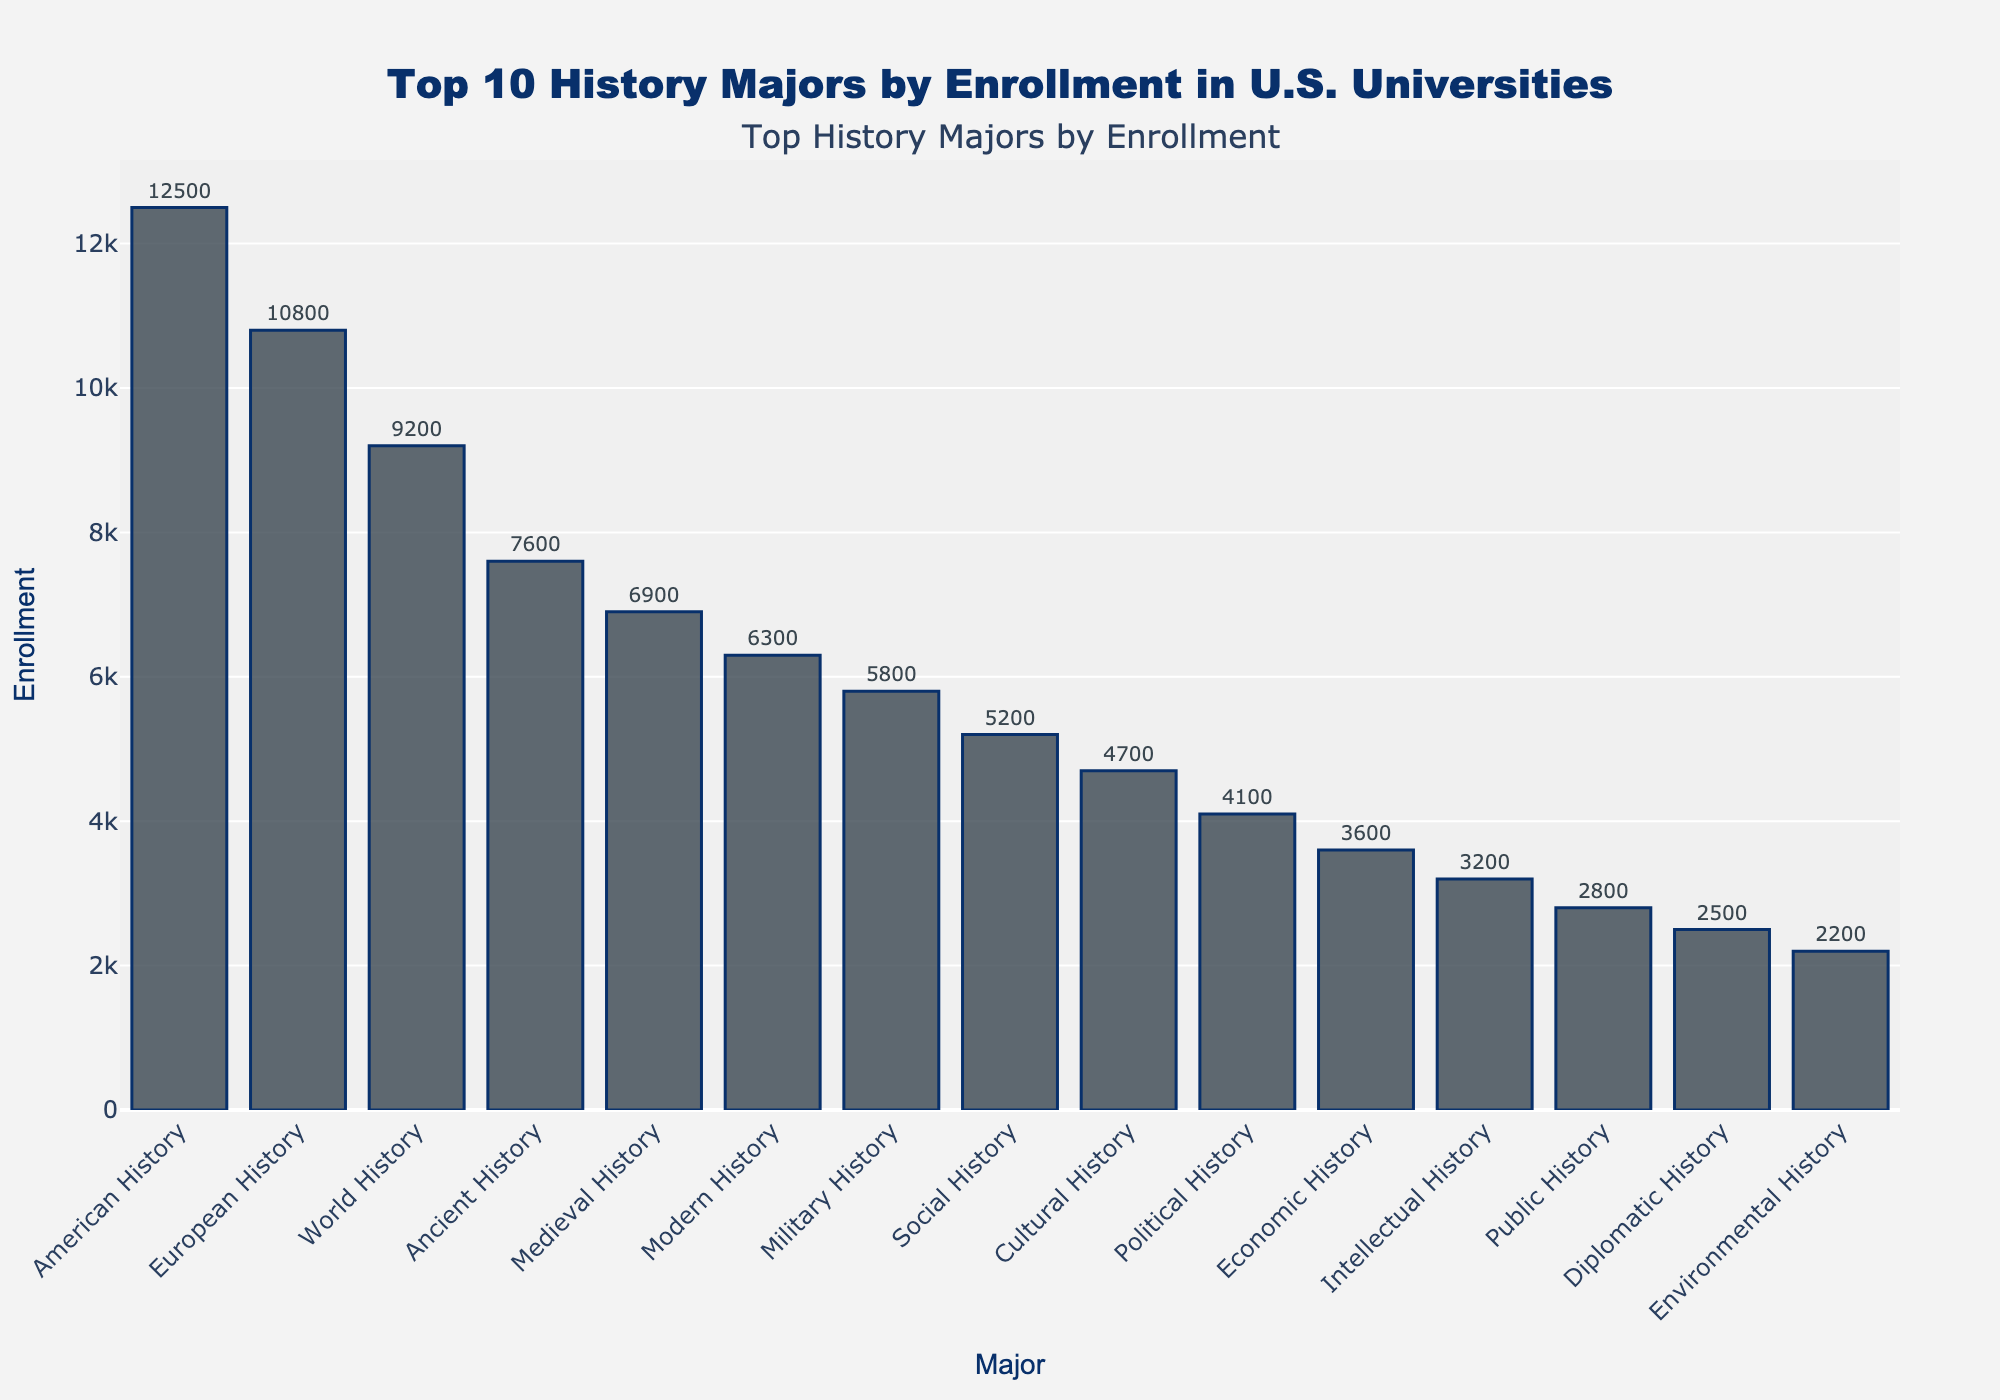What is the total enrollment for the top 5 history majors? To calculate the total enrollment for the top 5 history majors, sum the enrollment figures for American History (12,500), European History (10,800), World History (9,200), Ancient History (7,600), and Medieval History (6,900). So, 12,500 + 10,800 + 9,200 + 7,600 + 6,900 = 47,000.
Answer: 47,000 Which major has the highest enrollment? By looking at the height of the bars, the tallest bar represents American History with an enrollment of 12,500, making it the major with the highest enrollment.
Answer: American History How much greater is the enrollment of American History compared to Political History? Subtract the enrollment for Political History (4,100) from American History (12,500). So, 12,500 - 4,100 = 8,400.
Answer: 8,400 Identify the major with the lowest enrollment among the top 10. By observing the smallest bar among the top 10, Political History has an enrollment of 4,100, making it the major with the lowest enrollment in the top 10.
Answer: Political History What is the average enrollment for the top 4 history majors? To find the average, sum the enrollments of the top 4 majors (12,500 + 10,800 + 9,200 + 7,600) and divide by 4. So (12,500 + 10,800 + 9,200 + 7,600) / 4 = 40,100 / 4 = 10,025.
Answer: 10,025 How many majors have an enrollment number that is greater than 6,000? By looking at the bars, count the majors where the height indicates an enrollment over 6,000: American History, European History, World History, Ancient History, Medieval History, and Modern History. This gives a total of 6 majors.
Answer: 6 Which major has an enrollment closest to 5,000? Look at the bars and locate the enrollment number closest to 5,000. Social History has an enrollment of 5,200, which is the closest to 5,000.
Answer: Social History What is the difference in enrollment between the major with the second highest and the tenth highest enrollment? The major with the second highest enrollment is European History (10,800) and the tenth highest is Political History (4,100). The difference is 10,800 - 4,100 = 6,700.
Answer: 6,700 Considering only the top 3 majors, what percentage of the total enrollment does European History contribute? Sum the total enrollment for the top 3 majors (American History: 12,500, European History: 10,800, World History: 9,200) which is 12,500 + 10,800 + 9,200 = 32,500. European History's contribution is 10,800. So the percentage is (10,800 / 32,500) * 100 ≈ 33.23%.
Answer: 33.23% If enrollments for all majors except European History increased by 1,000 each, would American History still have the highest enrollment? Increase each major's enrollment by 1,000 except for European History. American History would become 13,500, European History remains at 10,800. All other majors increase similarly but none exceed 13,500, so American History maintains the highest enrollment.
Answer: Yes 